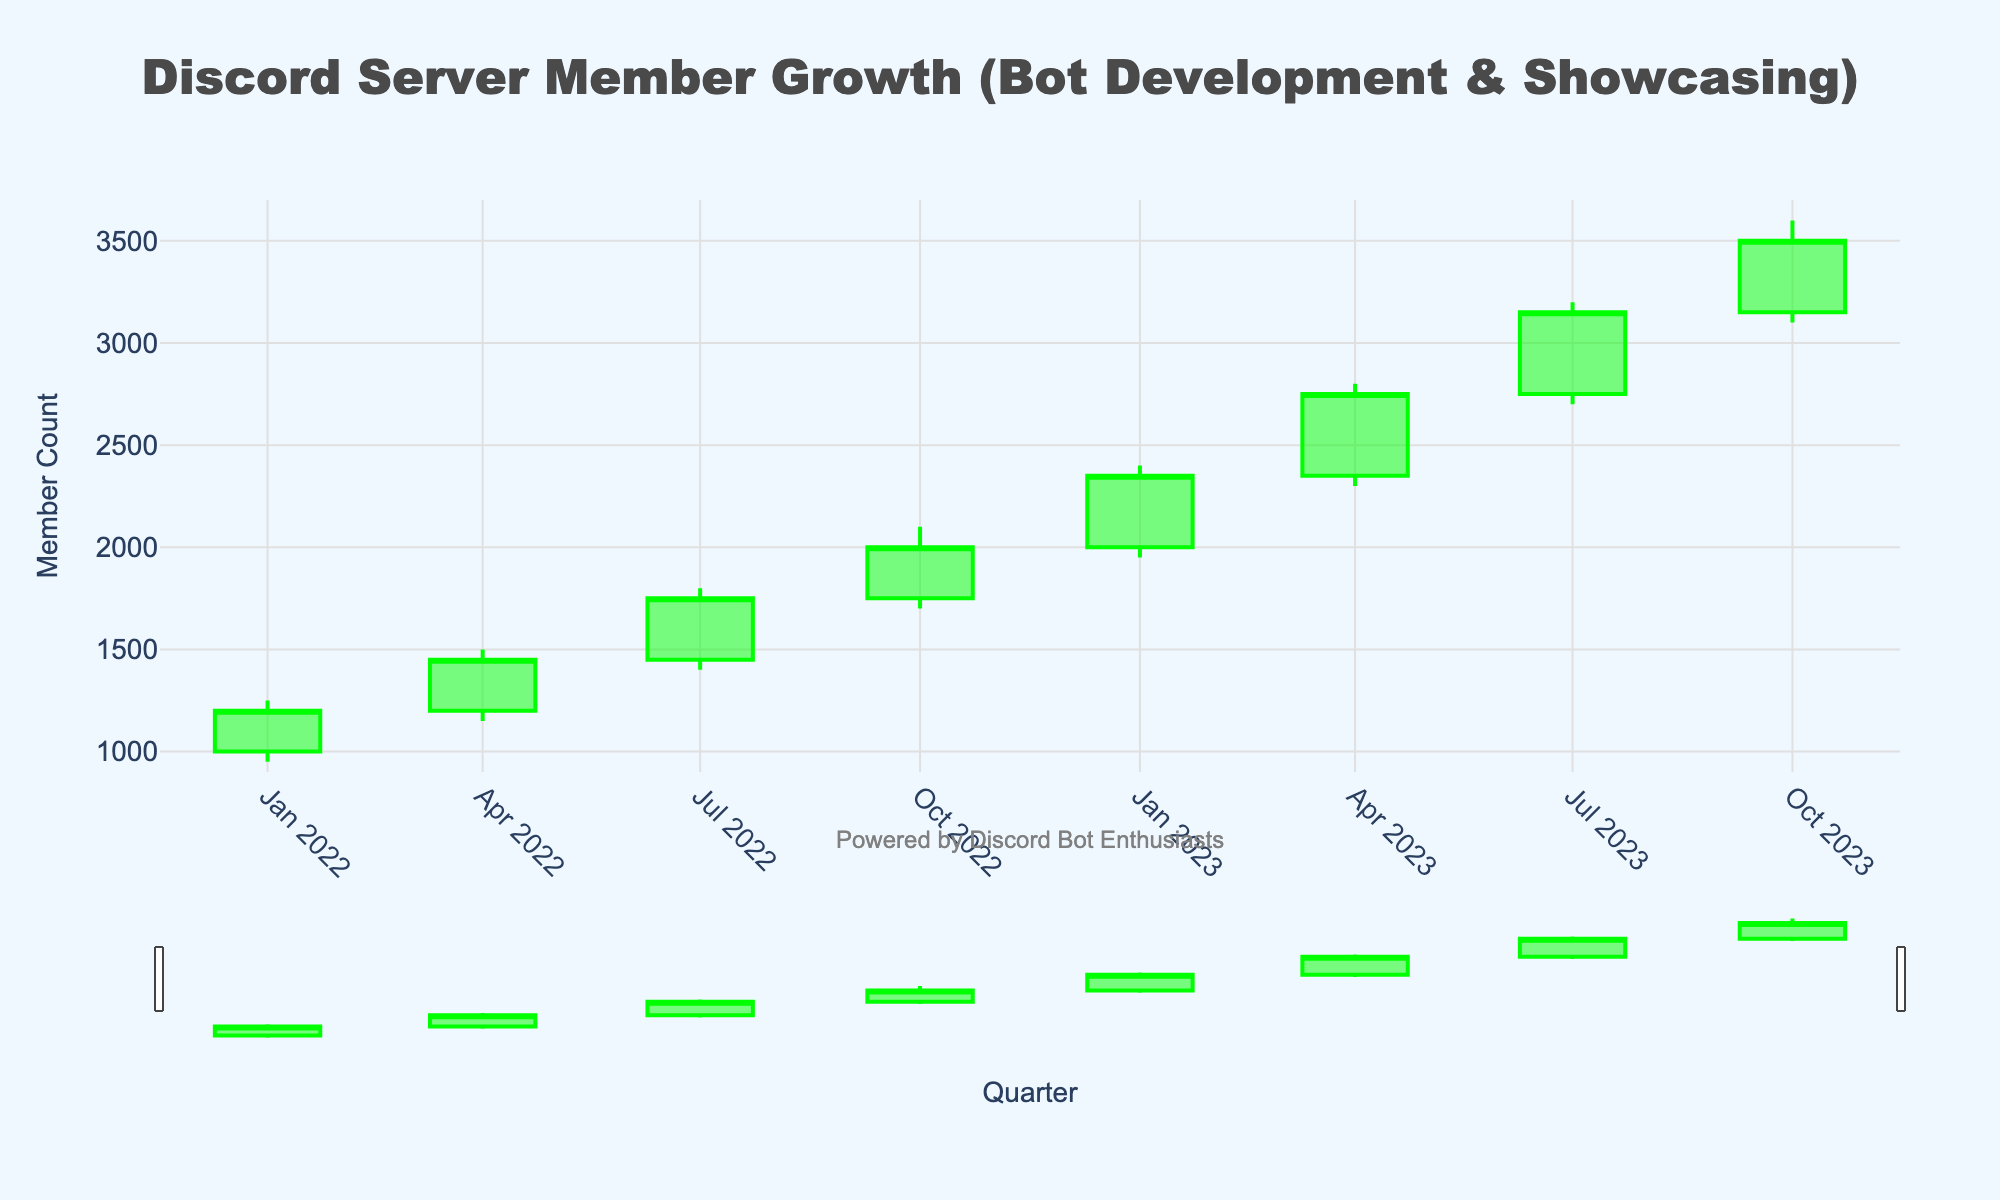What's the title of the figure? The title is displayed at the top of the figure and states, "Discord Server Member Growth (Bot Development & Showcasing)".
Answer: Discord Server Member Growth (Bot Development & Showcasing) What is the background color of the plot? The background color of the plot is visible and appears as a light blue shade.
Answer: Light blue In which quarter of 2023 did the Discord server member count first exceed 3000? Looking at the OHLC chart, the member count exceeded 3000 in 2023-Q3 as denoted by the close value of 3150.
Answer: 2023-Q3 Which quarter shows the highest member count spike? The highest member count spike can be observed by comparing the "high" values in each quarter. The value is highest in 2023-Q4 with a high of 3600.
Answer: 2023-Q4 What is the percentage growth from 2022-Q1 to 2023-Q4 at the close value? Calculate the percentage increase using the formula ((final value - initial value) / initial value) * 100. Initial value = 1200 (2022-Q1 close), final value = 3500 (2023-Q4 close).
Answer: 191.67% What was the member count range in 2023-Q2? The range can be found using the "low" and "high" values for 2023-Q2. The low is 2300 and the high is 2800. Hence, the range is 2800 - 2300.
Answer: 500 During which quarter did the member count decrease from its opening value, and by how much? In 2022-Q1, the member count decreased from the opening value of 1000 to the closing value of 1200. The decrease is calculated as 1200 - 1000.
Answer: -200 What is the average "high" value across all quarters? Add up all high values (1250, 1500, 1800, 2100, 2400, 2800, 3200, 3600) and divide by the number of quarters (8). Sum = 18650, average = 18650 / 8.
Answer: 2331.25 Which quarter had the greatest difference between the high and low values? Calculate the difference for each quarter. The greatest difference is in the quarter with the highest value. For example, in 2023-Q4 the difference is 500. Check other quarters similarly.
Answer: 2023-Q4 How did the member count change from the beginning to the end of 2022? Compare the close values of 2022-Q1 (1200) and 2022-Q4 (2000), calculating the difference by subtraction.
Answer: Increased by 800 